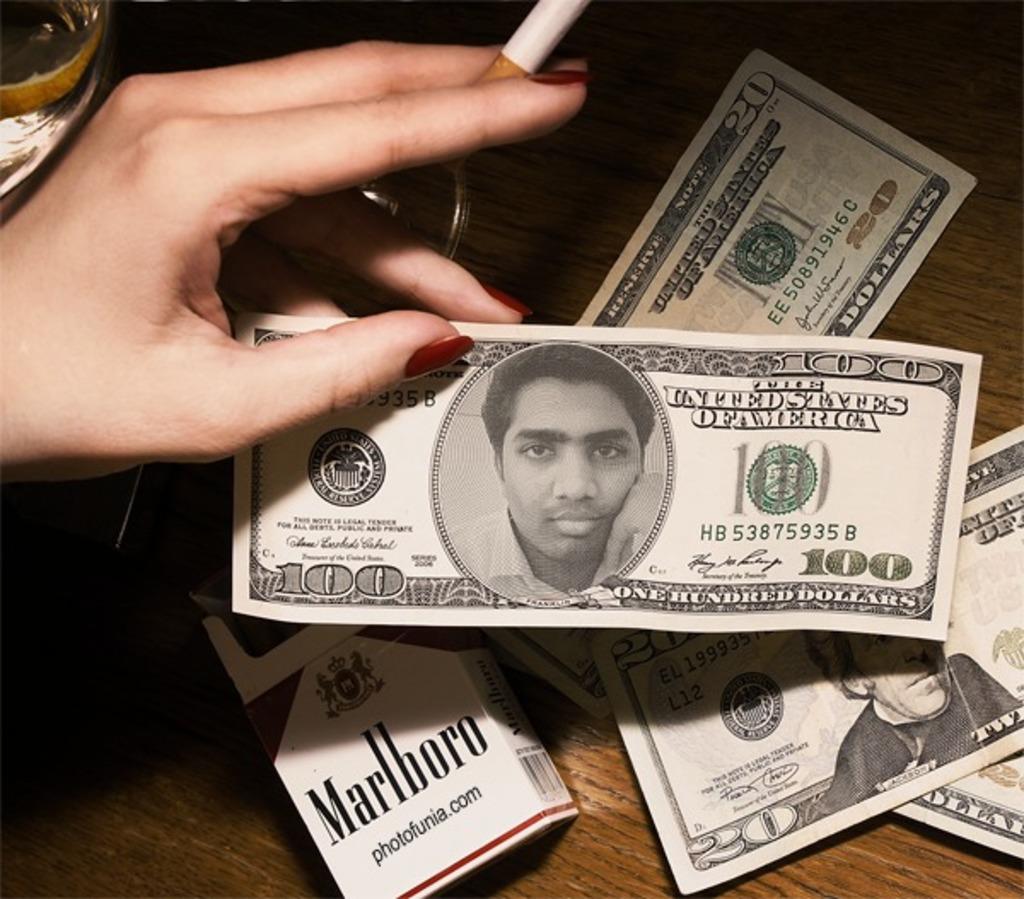What is the denomination of this fake currency?
Offer a terse response. 100. What brand of cigarettes?
Offer a very short reply. Marlboro. 